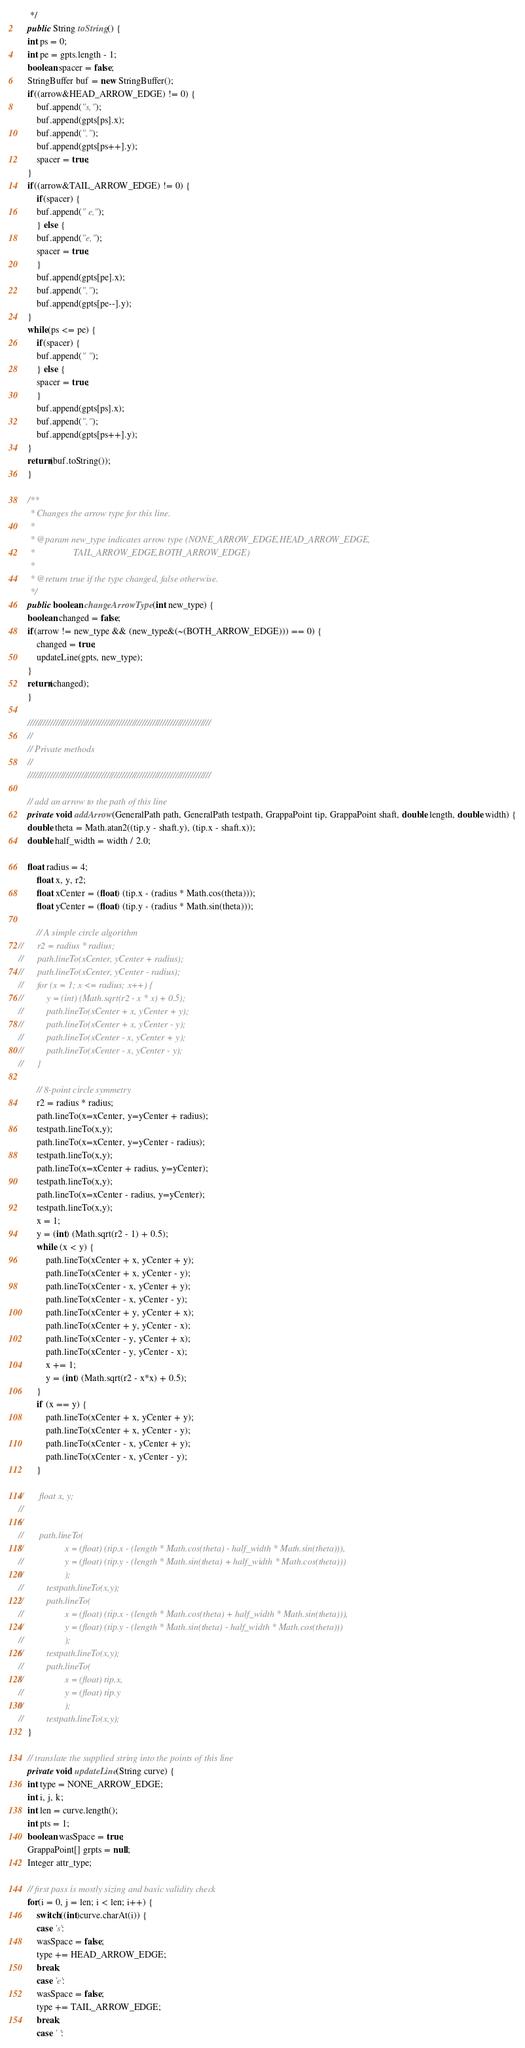Convert code to text. <code><loc_0><loc_0><loc_500><loc_500><_Java_>     */
    public String toString() {
	int ps = 0;
	int pe = gpts.length - 1;
	boolean spacer = false;
	StringBuffer buf = new StringBuffer();
	if((arrow&HEAD_ARROW_EDGE) != 0) {
	    buf.append("s,");
	    buf.append(gpts[ps].x);
	    buf.append(",");
	    buf.append(gpts[ps++].y);
	    spacer = true;
	}
	if((arrow&TAIL_ARROW_EDGE) != 0) {
	    if(spacer) {
		buf.append(" e,");
	    } else {
		buf.append("e,");
		spacer = true;
	    }
	    buf.append(gpts[pe].x);
	    buf.append(",");
	    buf.append(gpts[pe--].y);
	}
	while(ps <= pe) {
	    if(spacer) {
		buf.append(" ");
	    } else {
		spacer = true;
	    }
	    buf.append(gpts[ps].x);
	    buf.append(",");
	    buf.append(gpts[ps++].y);
	}
	return(buf.toString());
    }

    /**
     * Changes the arrow type for this line.
     *
     * @param new_type indicates arrow type (NONE_ARROW_EDGE,HEAD_ARROW_EDGE,
     *                 TAIL_ARROW_EDGE,BOTH_ARROW_EDGE)
     * 
     * @return true if the type changed, false otherwise.
     */
    public boolean changeArrowType(int new_type) {
	boolean changed = false;
	if(arrow != new_type && (new_type&(~(BOTH_ARROW_EDGE))) == 0) {
	    changed = true;
	    updateLine(gpts, new_type);
	}
	return(changed);
    }

    ////////////////////////////////////////////////////////////////////////
    //
    // Private methods
    //
    ////////////////////////////////////////////////////////////////////////

    // add an arrow to the path of this line
    private void addArrow(GeneralPath path, GeneralPath testpath, GrappaPoint tip, GrappaPoint shaft, double length, double width) {
	double theta = Math.atan2((tip.y - shaft.y), (tip.x - shaft.x));
	double half_width = width / 2.0;
	
	float radius = 4;
		float x, y, r2;
		float xCenter = (float) (tip.x - (radius * Math.cos(theta)));
		float yCenter = (float) (tip.y - (radius * Math.sin(theta)));

		// A simple circle algorithm
//		r2 = radius * radius;
//		path.lineTo(xCenter, yCenter + radius);
//		path.lineTo(xCenter, yCenter - radius);
//		for (x = 1; x <= radius; x++) {
//			y = (int) (Math.sqrt(r2 - x * x) + 0.5);
//			path.lineTo(xCenter + x, yCenter + y);
//			path.lineTo(xCenter + x, yCenter - y);
//			path.lineTo(xCenter - x, yCenter + y);
//			path.lineTo(xCenter - x, yCenter - y);
//		}
		
		// 8-point circle symmetry
        r2 = radius * radius;
        path.lineTo(x=xCenter, y=yCenter + radius);
        testpath.lineTo(x,y);
        path.lineTo(x=xCenter, y=yCenter - radius);
        testpath.lineTo(x,y);
        path.lineTo(x=xCenter + radius, y=yCenter);
        testpath.lineTo(x,y);
        path.lineTo(x=xCenter - radius, y=yCenter);
        testpath.lineTo(x,y);
        x = 1;
        y = (int) (Math.sqrt(r2 - 1) + 0.5);
        while (x < y) {
        	path.lineTo(xCenter + x, yCenter + y);
        	path.lineTo(xCenter + x, yCenter - y);
        	path.lineTo(xCenter - x, yCenter + y);
        	path.lineTo(xCenter - x, yCenter - y);
        	path.lineTo(xCenter + y, yCenter + x);
        	path.lineTo(xCenter + y, yCenter - x);
        	path.lineTo(xCenter - y, yCenter + x);
        	path.lineTo(xCenter - y, yCenter - x);
        	x += 1;
            y = (int) (Math.sqrt(r2 - x*x) + 0.5);
        }
        if (x == y) {
        	path.lineTo(xCenter + x, yCenter + y);
        	path.lineTo(xCenter + x, yCenter - y);
        	path.lineTo(xCenter - x, yCenter + y);
        	path.lineTo(xCenter - x, yCenter - y);
        }
		
//		 float x, y;
//			
//			
//		 path.lineTo(
//				    x = (float) (tip.x - (length * Math.cos(theta) - half_width * Math.sin(theta))),
//				    y = (float) (tip.y - (length * Math.sin(theta) + half_width * Math.cos(theta)))
//				    );
//			testpath.lineTo(x,y);
//			path.lineTo(
//				    x = (float) (tip.x - (length * Math.cos(theta) + half_width * Math.sin(theta))),
//				    y = (float) (tip.y - (length * Math.sin(theta) - half_width * Math.cos(theta)))
//				    );
//			testpath.lineTo(x,y);
//			path.lineTo(
//				    x = (float) tip.x,
//				    y = (float) tip.y
//				    );
//			testpath.lineTo(x,y);
    } 

    // translate the supplied string into the points of this line
    private void updateLine(String curve) {
	int type = NONE_ARROW_EDGE;
	int i, j, k;
	int len = curve.length();
	int pts = 1;
	boolean wasSpace = true;
	GrappaPoint[] grpts = null;
	Integer attr_type;

	// first pass is mostly sizing and basic validity check
	for(i = 0, j = len; i < len; i++) {
	    switch((int)curve.charAt(i)) {
	    case 's':
		wasSpace = false;
		type += HEAD_ARROW_EDGE;
		break;
	    case 'e':
		wasSpace = false;
		type += TAIL_ARROW_EDGE;
		break;
	    case ' ':</code> 